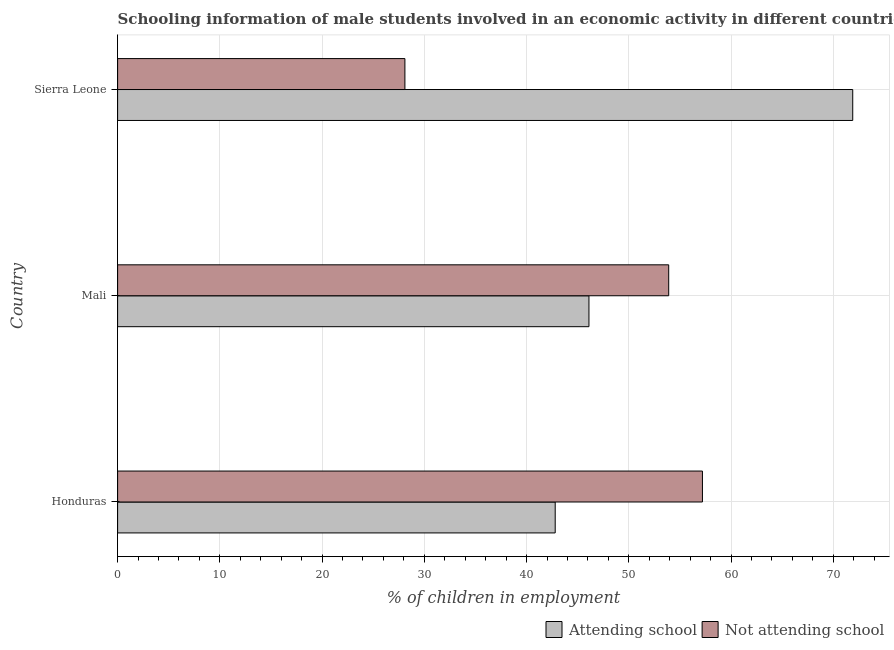How many different coloured bars are there?
Provide a succinct answer. 2. Are the number of bars per tick equal to the number of legend labels?
Your answer should be compact. Yes. Are the number of bars on each tick of the Y-axis equal?
Keep it short and to the point. Yes. How many bars are there on the 2nd tick from the top?
Your response must be concise. 2. What is the label of the 3rd group of bars from the top?
Your answer should be compact. Honduras. In how many cases, is the number of bars for a given country not equal to the number of legend labels?
Offer a terse response. 0. What is the percentage of employed males who are not attending school in Mali?
Provide a short and direct response. 53.9. Across all countries, what is the maximum percentage of employed males who are not attending school?
Give a very brief answer. 57.2. Across all countries, what is the minimum percentage of employed males who are not attending school?
Your answer should be very brief. 28.1. In which country was the percentage of employed males who are not attending school maximum?
Keep it short and to the point. Honduras. In which country was the percentage of employed males who are not attending school minimum?
Keep it short and to the point. Sierra Leone. What is the total percentage of employed males who are not attending school in the graph?
Offer a terse response. 139.2. What is the difference between the percentage of employed males who are not attending school in Honduras and that in Mali?
Your answer should be very brief. 3.3. What is the difference between the percentage of employed males who are not attending school in Mali and the percentage of employed males who are attending school in Honduras?
Ensure brevity in your answer.  11.1. What is the average percentage of employed males who are not attending school per country?
Your answer should be very brief. 46.4. What is the difference between the percentage of employed males who are attending school and percentage of employed males who are not attending school in Mali?
Provide a succinct answer. -7.8. In how many countries, is the percentage of employed males who are attending school greater than 10 %?
Give a very brief answer. 3. What is the ratio of the percentage of employed males who are attending school in Honduras to that in Sierra Leone?
Offer a terse response. 0.59. What is the difference between the highest and the second highest percentage of employed males who are attending school?
Ensure brevity in your answer.  25.8. What is the difference between the highest and the lowest percentage of employed males who are not attending school?
Your response must be concise. 29.1. In how many countries, is the percentage of employed males who are not attending school greater than the average percentage of employed males who are not attending school taken over all countries?
Keep it short and to the point. 2. Is the sum of the percentage of employed males who are not attending school in Honduras and Mali greater than the maximum percentage of employed males who are attending school across all countries?
Your answer should be very brief. Yes. What does the 1st bar from the top in Sierra Leone represents?
Make the answer very short. Not attending school. What does the 2nd bar from the bottom in Honduras represents?
Keep it short and to the point. Not attending school. How many bars are there?
Your answer should be compact. 6. Are all the bars in the graph horizontal?
Provide a succinct answer. Yes. How many countries are there in the graph?
Provide a short and direct response. 3. What is the difference between two consecutive major ticks on the X-axis?
Give a very brief answer. 10. Does the graph contain grids?
Give a very brief answer. Yes. What is the title of the graph?
Your answer should be compact. Schooling information of male students involved in an economic activity in different countries. Does "Arms exports" appear as one of the legend labels in the graph?
Ensure brevity in your answer.  No. What is the label or title of the X-axis?
Keep it short and to the point. % of children in employment. What is the % of children in employment in Attending school in Honduras?
Offer a very short reply. 42.8. What is the % of children in employment in Not attending school in Honduras?
Keep it short and to the point. 57.2. What is the % of children in employment of Attending school in Mali?
Keep it short and to the point. 46.1. What is the % of children in employment in Not attending school in Mali?
Give a very brief answer. 53.9. What is the % of children in employment in Attending school in Sierra Leone?
Keep it short and to the point. 71.9. What is the % of children in employment of Not attending school in Sierra Leone?
Offer a terse response. 28.1. Across all countries, what is the maximum % of children in employment of Attending school?
Keep it short and to the point. 71.9. Across all countries, what is the maximum % of children in employment in Not attending school?
Keep it short and to the point. 57.2. Across all countries, what is the minimum % of children in employment of Attending school?
Your answer should be compact. 42.8. Across all countries, what is the minimum % of children in employment of Not attending school?
Keep it short and to the point. 28.1. What is the total % of children in employment in Attending school in the graph?
Your answer should be compact. 160.8. What is the total % of children in employment of Not attending school in the graph?
Your answer should be compact. 139.2. What is the difference between the % of children in employment of Attending school in Honduras and that in Sierra Leone?
Offer a terse response. -29.1. What is the difference between the % of children in employment of Not attending school in Honduras and that in Sierra Leone?
Your response must be concise. 29.1. What is the difference between the % of children in employment of Attending school in Mali and that in Sierra Leone?
Your answer should be compact. -25.8. What is the difference between the % of children in employment of Not attending school in Mali and that in Sierra Leone?
Keep it short and to the point. 25.8. What is the difference between the % of children in employment in Attending school in Mali and the % of children in employment in Not attending school in Sierra Leone?
Make the answer very short. 18. What is the average % of children in employment in Attending school per country?
Your answer should be very brief. 53.6. What is the average % of children in employment in Not attending school per country?
Offer a terse response. 46.4. What is the difference between the % of children in employment in Attending school and % of children in employment in Not attending school in Honduras?
Keep it short and to the point. -14.4. What is the difference between the % of children in employment of Attending school and % of children in employment of Not attending school in Sierra Leone?
Provide a succinct answer. 43.8. What is the ratio of the % of children in employment of Attending school in Honduras to that in Mali?
Provide a succinct answer. 0.93. What is the ratio of the % of children in employment in Not attending school in Honduras to that in Mali?
Keep it short and to the point. 1.06. What is the ratio of the % of children in employment of Attending school in Honduras to that in Sierra Leone?
Give a very brief answer. 0.6. What is the ratio of the % of children in employment in Not attending school in Honduras to that in Sierra Leone?
Your answer should be very brief. 2.04. What is the ratio of the % of children in employment of Attending school in Mali to that in Sierra Leone?
Give a very brief answer. 0.64. What is the ratio of the % of children in employment of Not attending school in Mali to that in Sierra Leone?
Make the answer very short. 1.92. What is the difference between the highest and the second highest % of children in employment in Attending school?
Make the answer very short. 25.8. What is the difference between the highest and the second highest % of children in employment in Not attending school?
Offer a terse response. 3.3. What is the difference between the highest and the lowest % of children in employment of Attending school?
Keep it short and to the point. 29.1. What is the difference between the highest and the lowest % of children in employment of Not attending school?
Provide a short and direct response. 29.1. 